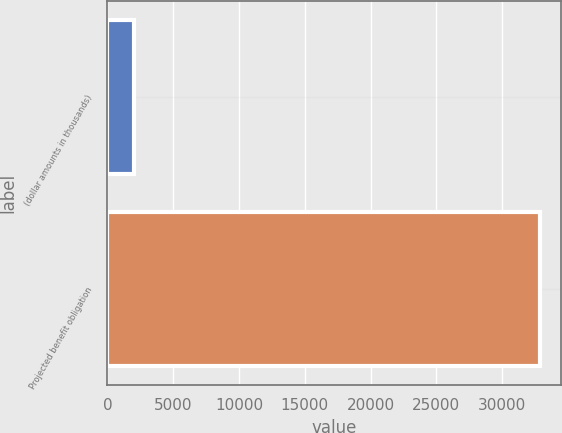Convert chart. <chart><loc_0><loc_0><loc_500><loc_500><bar_chart><fcel>(dollar amounts in thousands)<fcel>Projected benefit obligation<nl><fcel>2012<fcel>32851<nl></chart> 